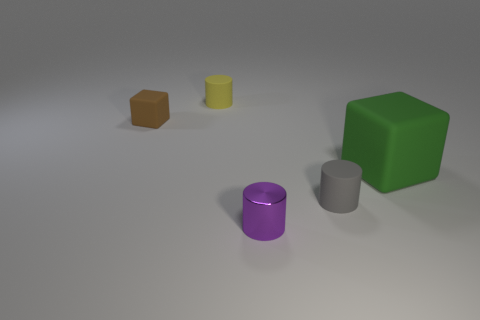Is there any other thing that is the same size as the green rubber object?
Your answer should be very brief. No. Is there any other thing that has the same material as the small purple cylinder?
Your response must be concise. No. What number of other things are there of the same size as the green rubber block?
Provide a short and direct response. 0. What is the material of the small cylinder that is behind the matte cylinder in front of the object on the right side of the gray matte cylinder?
Provide a succinct answer. Rubber. How many blocks are green objects or tiny shiny objects?
Offer a very short reply. 1. Is there anything else that has the same shape as the tiny shiny thing?
Your answer should be very brief. Yes. Is the number of cylinders in front of the yellow object greater than the number of green matte cubes that are behind the tiny gray rubber cylinder?
Offer a terse response. Yes. What number of tiny brown rubber things are on the right side of the small cylinder that is behind the large green object?
Keep it short and to the point. 0. How many objects are cyan matte blocks or green objects?
Your answer should be very brief. 1. Do the big green thing and the brown thing have the same shape?
Offer a very short reply. Yes. 